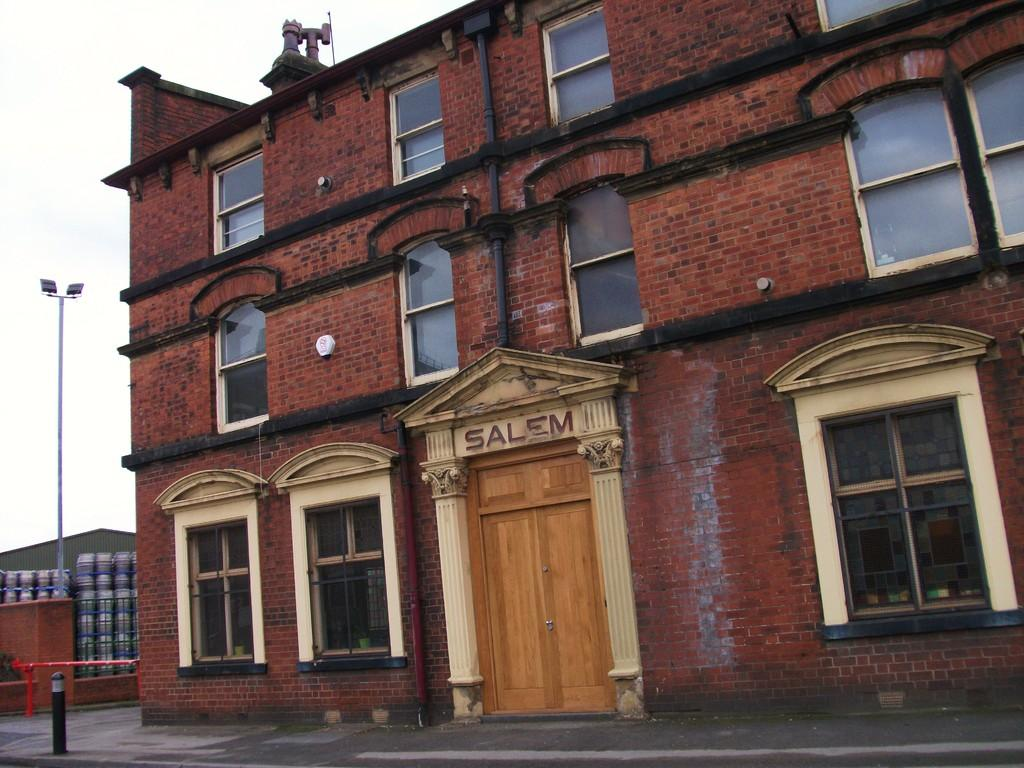What type of structures can be seen in the image? There are buildings in the image. What is the purpose of the fence in the image? The fence is likely used to separate or enclose areas in the image. Can you describe the light in the image? There is a light in the image, which could be a street light or a light attached to a building. What architectural features are present in the image? There are windows and a door visible in the image. What is visible in the background of the image? The sky is visible in the image. What type of yarn is being used to grow the tooth in the image? There is no yarn, growth, or tooth present in the image. 